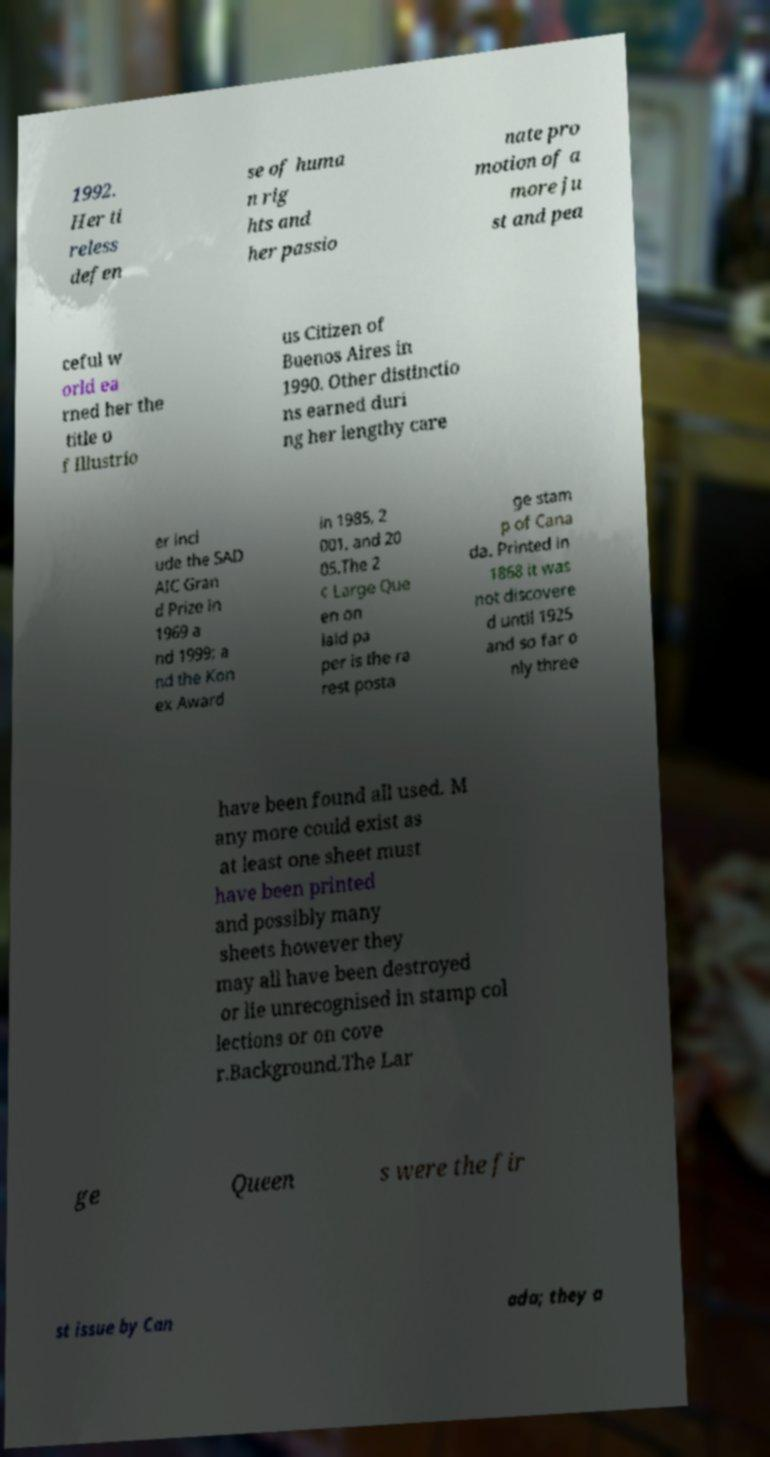What messages or text are displayed in this image? I need them in a readable, typed format. 1992. Her ti reless defen se of huma n rig hts and her passio nate pro motion of a more ju st and pea ceful w orld ea rned her the title o f Illustrio us Citizen of Buenos Aires in 1990. Other distinctio ns earned duri ng her lengthy care er incl ude the SAD AIC Gran d Prize in 1969 a nd 1999; a nd the Kon ex Award in 1985, 2 001, and 20 05.The 2 ¢ Large Que en on laid pa per is the ra rest posta ge stam p of Cana da. Printed in 1868 it was not discovere d until 1925 and so far o nly three have been found all used. M any more could exist as at least one sheet must have been printed and possibly many sheets however they may all have been destroyed or lie unrecognised in stamp col lections or on cove r.Background.The Lar ge Queen s were the fir st issue by Can ada; they a 